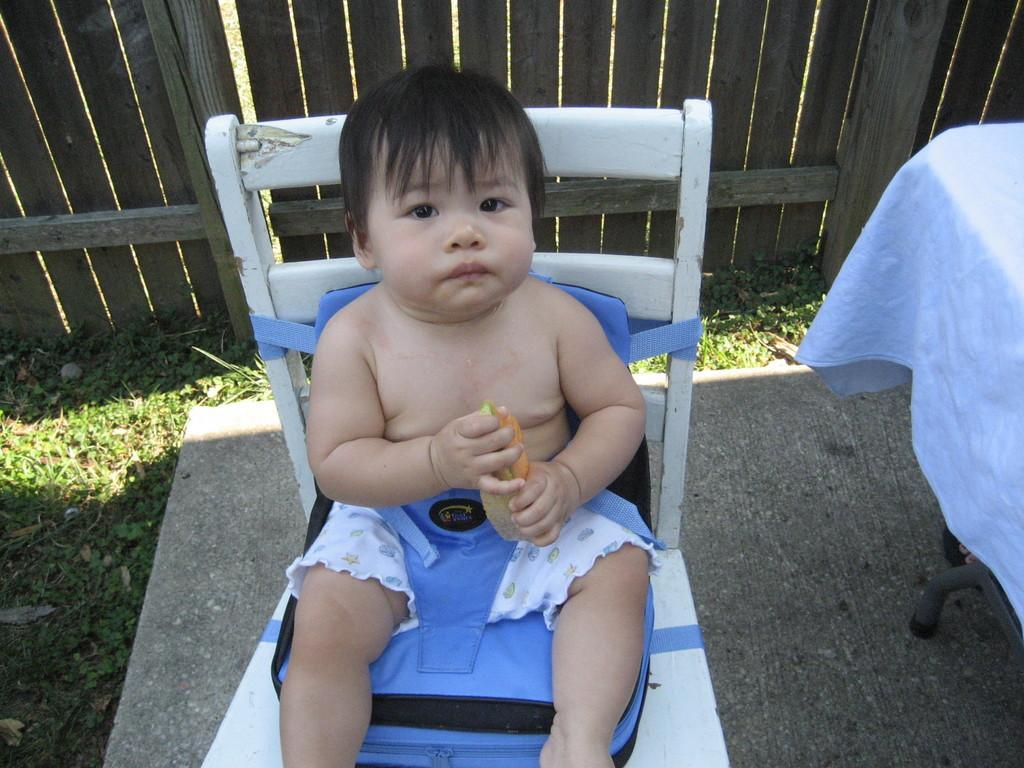In one or two sentences, can you explain what this image depicts? In this image I can see the child sitting on the chair. The child is wearing the white color pant. To the side there is a table and I can see the white sheet on it. In the background there is a wooden fence. 